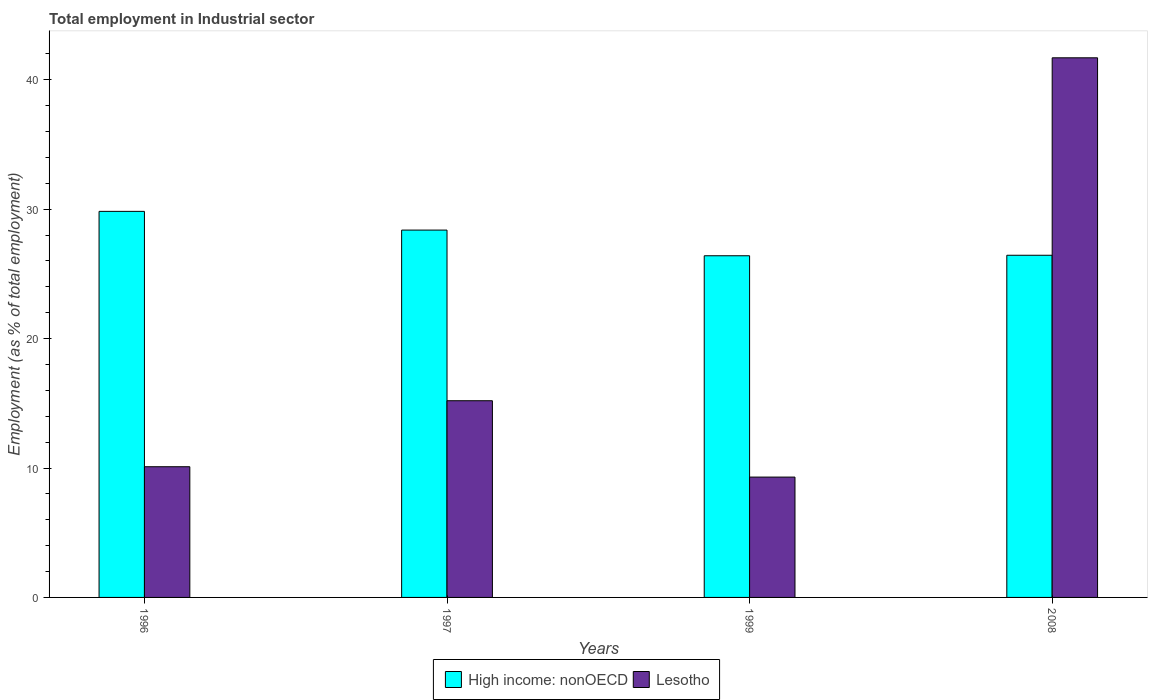How many different coloured bars are there?
Offer a very short reply. 2. Are the number of bars on each tick of the X-axis equal?
Provide a succinct answer. Yes. How many bars are there on the 1st tick from the left?
Offer a terse response. 2. What is the label of the 2nd group of bars from the left?
Give a very brief answer. 1997. What is the employment in industrial sector in Lesotho in 2008?
Offer a very short reply. 41.7. Across all years, what is the maximum employment in industrial sector in High income: nonOECD?
Ensure brevity in your answer.  29.83. Across all years, what is the minimum employment in industrial sector in High income: nonOECD?
Keep it short and to the point. 26.4. In which year was the employment in industrial sector in High income: nonOECD maximum?
Your answer should be very brief. 1996. What is the total employment in industrial sector in High income: nonOECD in the graph?
Provide a succinct answer. 111.06. What is the difference between the employment in industrial sector in Lesotho in 1996 and that in 1997?
Keep it short and to the point. -5.1. What is the difference between the employment in industrial sector in High income: nonOECD in 2008 and the employment in industrial sector in Lesotho in 1997?
Provide a succinct answer. 11.24. What is the average employment in industrial sector in Lesotho per year?
Make the answer very short. 19.08. In the year 1997, what is the difference between the employment in industrial sector in High income: nonOECD and employment in industrial sector in Lesotho?
Your answer should be very brief. 13.19. What is the ratio of the employment in industrial sector in High income: nonOECD in 1996 to that in 2008?
Offer a terse response. 1.13. Is the employment in industrial sector in High income: nonOECD in 1997 less than that in 1999?
Your answer should be compact. No. Is the difference between the employment in industrial sector in High income: nonOECD in 1996 and 1999 greater than the difference between the employment in industrial sector in Lesotho in 1996 and 1999?
Offer a very short reply. Yes. What is the difference between the highest and the second highest employment in industrial sector in High income: nonOECD?
Offer a very short reply. 1.45. What is the difference between the highest and the lowest employment in industrial sector in High income: nonOECD?
Offer a terse response. 3.43. Is the sum of the employment in industrial sector in High income: nonOECD in 1996 and 1999 greater than the maximum employment in industrial sector in Lesotho across all years?
Provide a short and direct response. Yes. What does the 2nd bar from the left in 1999 represents?
Offer a terse response. Lesotho. What does the 2nd bar from the right in 1999 represents?
Provide a succinct answer. High income: nonOECD. Are all the bars in the graph horizontal?
Give a very brief answer. No. Does the graph contain any zero values?
Provide a succinct answer. No. Where does the legend appear in the graph?
Give a very brief answer. Bottom center. What is the title of the graph?
Offer a terse response. Total employment in Industrial sector. Does "Syrian Arab Republic" appear as one of the legend labels in the graph?
Keep it short and to the point. No. What is the label or title of the X-axis?
Provide a short and direct response. Years. What is the label or title of the Y-axis?
Make the answer very short. Employment (as % of total employment). What is the Employment (as % of total employment) of High income: nonOECD in 1996?
Give a very brief answer. 29.83. What is the Employment (as % of total employment) in Lesotho in 1996?
Ensure brevity in your answer.  10.1. What is the Employment (as % of total employment) of High income: nonOECD in 1997?
Give a very brief answer. 28.39. What is the Employment (as % of total employment) of Lesotho in 1997?
Your answer should be compact. 15.2. What is the Employment (as % of total employment) in High income: nonOECD in 1999?
Your response must be concise. 26.4. What is the Employment (as % of total employment) in Lesotho in 1999?
Give a very brief answer. 9.3. What is the Employment (as % of total employment) in High income: nonOECD in 2008?
Provide a short and direct response. 26.44. What is the Employment (as % of total employment) in Lesotho in 2008?
Your answer should be compact. 41.7. Across all years, what is the maximum Employment (as % of total employment) of High income: nonOECD?
Provide a short and direct response. 29.83. Across all years, what is the maximum Employment (as % of total employment) in Lesotho?
Keep it short and to the point. 41.7. Across all years, what is the minimum Employment (as % of total employment) in High income: nonOECD?
Your response must be concise. 26.4. Across all years, what is the minimum Employment (as % of total employment) of Lesotho?
Offer a terse response. 9.3. What is the total Employment (as % of total employment) of High income: nonOECD in the graph?
Give a very brief answer. 111.06. What is the total Employment (as % of total employment) of Lesotho in the graph?
Make the answer very short. 76.3. What is the difference between the Employment (as % of total employment) in High income: nonOECD in 1996 and that in 1997?
Your answer should be compact. 1.45. What is the difference between the Employment (as % of total employment) in High income: nonOECD in 1996 and that in 1999?
Give a very brief answer. 3.43. What is the difference between the Employment (as % of total employment) of Lesotho in 1996 and that in 1999?
Your response must be concise. 0.8. What is the difference between the Employment (as % of total employment) in High income: nonOECD in 1996 and that in 2008?
Offer a terse response. 3.39. What is the difference between the Employment (as % of total employment) of Lesotho in 1996 and that in 2008?
Give a very brief answer. -31.6. What is the difference between the Employment (as % of total employment) in High income: nonOECD in 1997 and that in 1999?
Your answer should be compact. 1.98. What is the difference between the Employment (as % of total employment) in Lesotho in 1997 and that in 1999?
Your response must be concise. 5.9. What is the difference between the Employment (as % of total employment) in High income: nonOECD in 1997 and that in 2008?
Give a very brief answer. 1.95. What is the difference between the Employment (as % of total employment) of Lesotho in 1997 and that in 2008?
Give a very brief answer. -26.5. What is the difference between the Employment (as % of total employment) of High income: nonOECD in 1999 and that in 2008?
Provide a succinct answer. -0.04. What is the difference between the Employment (as % of total employment) of Lesotho in 1999 and that in 2008?
Make the answer very short. -32.4. What is the difference between the Employment (as % of total employment) of High income: nonOECD in 1996 and the Employment (as % of total employment) of Lesotho in 1997?
Offer a terse response. 14.63. What is the difference between the Employment (as % of total employment) of High income: nonOECD in 1996 and the Employment (as % of total employment) of Lesotho in 1999?
Your response must be concise. 20.53. What is the difference between the Employment (as % of total employment) in High income: nonOECD in 1996 and the Employment (as % of total employment) in Lesotho in 2008?
Make the answer very short. -11.87. What is the difference between the Employment (as % of total employment) in High income: nonOECD in 1997 and the Employment (as % of total employment) in Lesotho in 1999?
Provide a short and direct response. 19.09. What is the difference between the Employment (as % of total employment) of High income: nonOECD in 1997 and the Employment (as % of total employment) of Lesotho in 2008?
Offer a terse response. -13.31. What is the difference between the Employment (as % of total employment) in High income: nonOECD in 1999 and the Employment (as % of total employment) in Lesotho in 2008?
Keep it short and to the point. -15.3. What is the average Employment (as % of total employment) in High income: nonOECD per year?
Provide a succinct answer. 27.77. What is the average Employment (as % of total employment) in Lesotho per year?
Provide a succinct answer. 19.07. In the year 1996, what is the difference between the Employment (as % of total employment) of High income: nonOECD and Employment (as % of total employment) of Lesotho?
Provide a short and direct response. 19.73. In the year 1997, what is the difference between the Employment (as % of total employment) of High income: nonOECD and Employment (as % of total employment) of Lesotho?
Keep it short and to the point. 13.19. In the year 1999, what is the difference between the Employment (as % of total employment) in High income: nonOECD and Employment (as % of total employment) in Lesotho?
Offer a terse response. 17.1. In the year 2008, what is the difference between the Employment (as % of total employment) of High income: nonOECD and Employment (as % of total employment) of Lesotho?
Your answer should be very brief. -15.26. What is the ratio of the Employment (as % of total employment) of High income: nonOECD in 1996 to that in 1997?
Keep it short and to the point. 1.05. What is the ratio of the Employment (as % of total employment) in Lesotho in 1996 to that in 1997?
Offer a terse response. 0.66. What is the ratio of the Employment (as % of total employment) in High income: nonOECD in 1996 to that in 1999?
Your response must be concise. 1.13. What is the ratio of the Employment (as % of total employment) of Lesotho in 1996 to that in 1999?
Offer a terse response. 1.09. What is the ratio of the Employment (as % of total employment) in High income: nonOECD in 1996 to that in 2008?
Provide a short and direct response. 1.13. What is the ratio of the Employment (as % of total employment) in Lesotho in 1996 to that in 2008?
Provide a succinct answer. 0.24. What is the ratio of the Employment (as % of total employment) in High income: nonOECD in 1997 to that in 1999?
Offer a terse response. 1.08. What is the ratio of the Employment (as % of total employment) of Lesotho in 1997 to that in 1999?
Ensure brevity in your answer.  1.63. What is the ratio of the Employment (as % of total employment) of High income: nonOECD in 1997 to that in 2008?
Give a very brief answer. 1.07. What is the ratio of the Employment (as % of total employment) of Lesotho in 1997 to that in 2008?
Your answer should be compact. 0.36. What is the ratio of the Employment (as % of total employment) in Lesotho in 1999 to that in 2008?
Provide a succinct answer. 0.22. What is the difference between the highest and the second highest Employment (as % of total employment) in High income: nonOECD?
Offer a very short reply. 1.45. What is the difference between the highest and the lowest Employment (as % of total employment) of High income: nonOECD?
Provide a succinct answer. 3.43. What is the difference between the highest and the lowest Employment (as % of total employment) in Lesotho?
Your response must be concise. 32.4. 